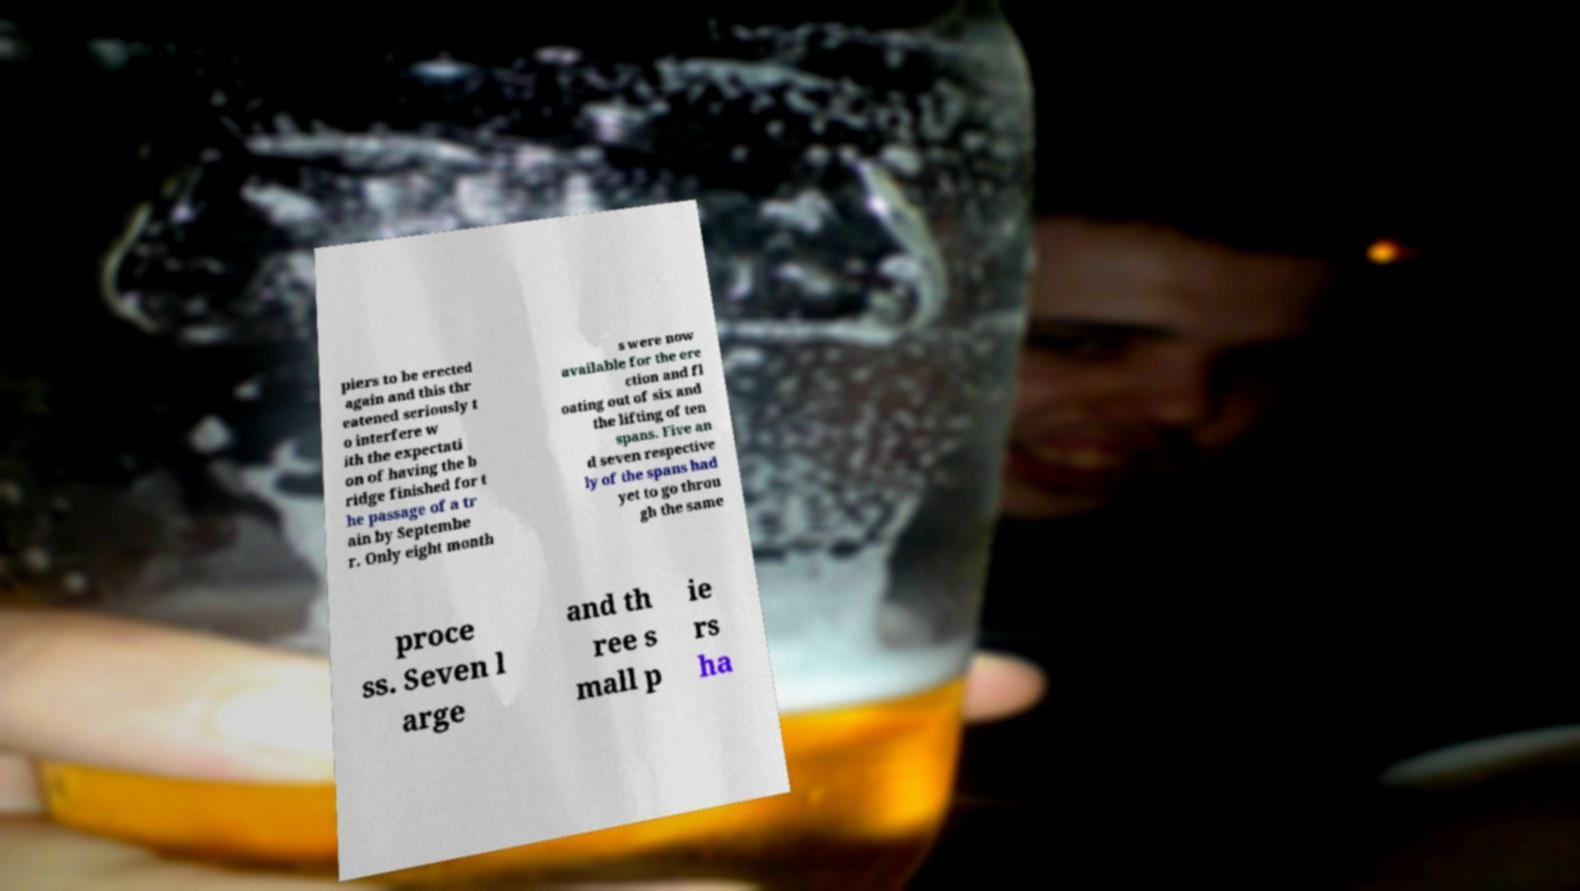Could you extract and type out the text from this image? piers to be erected again and this thr eatened seriously t o interfere w ith the expectati on of having the b ridge finished for t he passage of a tr ain by Septembe r. Only eight month s were now available for the ere ction and fl oating out of six and the lifting of ten spans. Five an d seven respective ly of the spans had yet to go throu gh the same proce ss. Seven l arge and th ree s mall p ie rs ha 